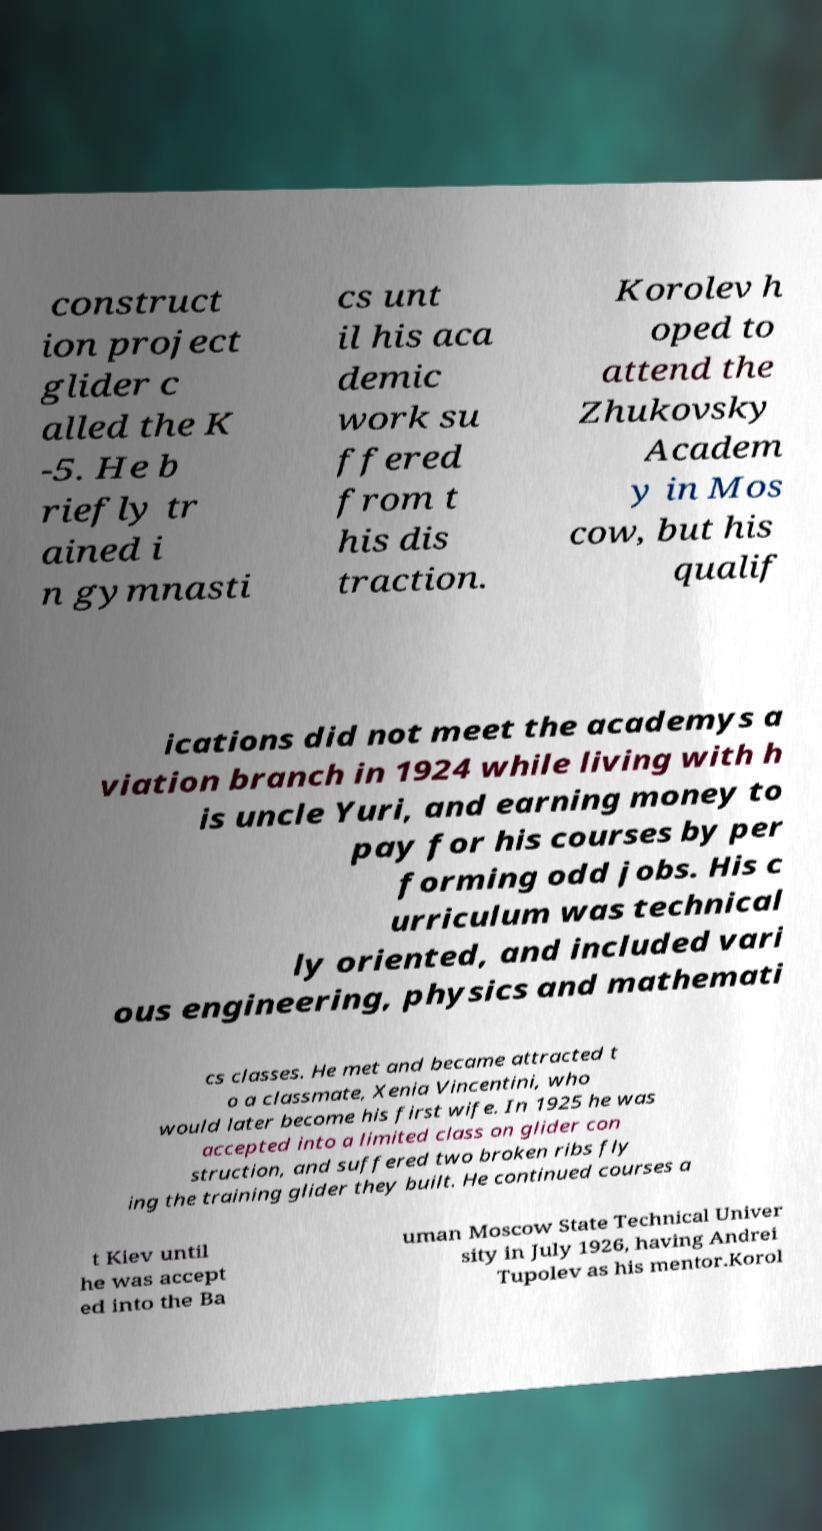Can you accurately transcribe the text from the provided image for me? construct ion project glider c alled the K -5. He b riefly tr ained i n gymnasti cs unt il his aca demic work su ffered from t his dis traction. Korolev h oped to attend the Zhukovsky Academ y in Mos cow, but his qualif ications did not meet the academys a viation branch in 1924 while living with h is uncle Yuri, and earning money to pay for his courses by per forming odd jobs. His c urriculum was technical ly oriented, and included vari ous engineering, physics and mathemati cs classes. He met and became attracted t o a classmate, Xenia Vincentini, who would later become his first wife. In 1925 he was accepted into a limited class on glider con struction, and suffered two broken ribs fly ing the training glider they built. He continued courses a t Kiev until he was accept ed into the Ba uman Moscow State Technical Univer sity in July 1926, having Andrei Tupolev as his mentor.Korol 